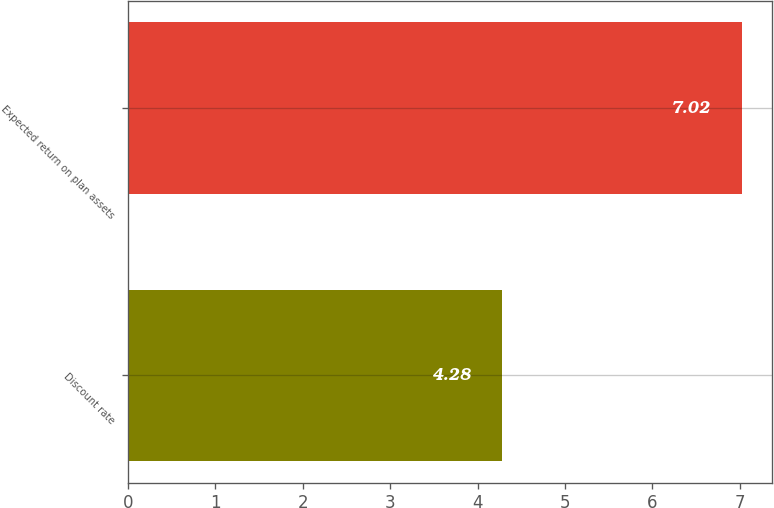Convert chart. <chart><loc_0><loc_0><loc_500><loc_500><bar_chart><fcel>Discount rate<fcel>Expected return on plan assets<nl><fcel>4.28<fcel>7.02<nl></chart> 